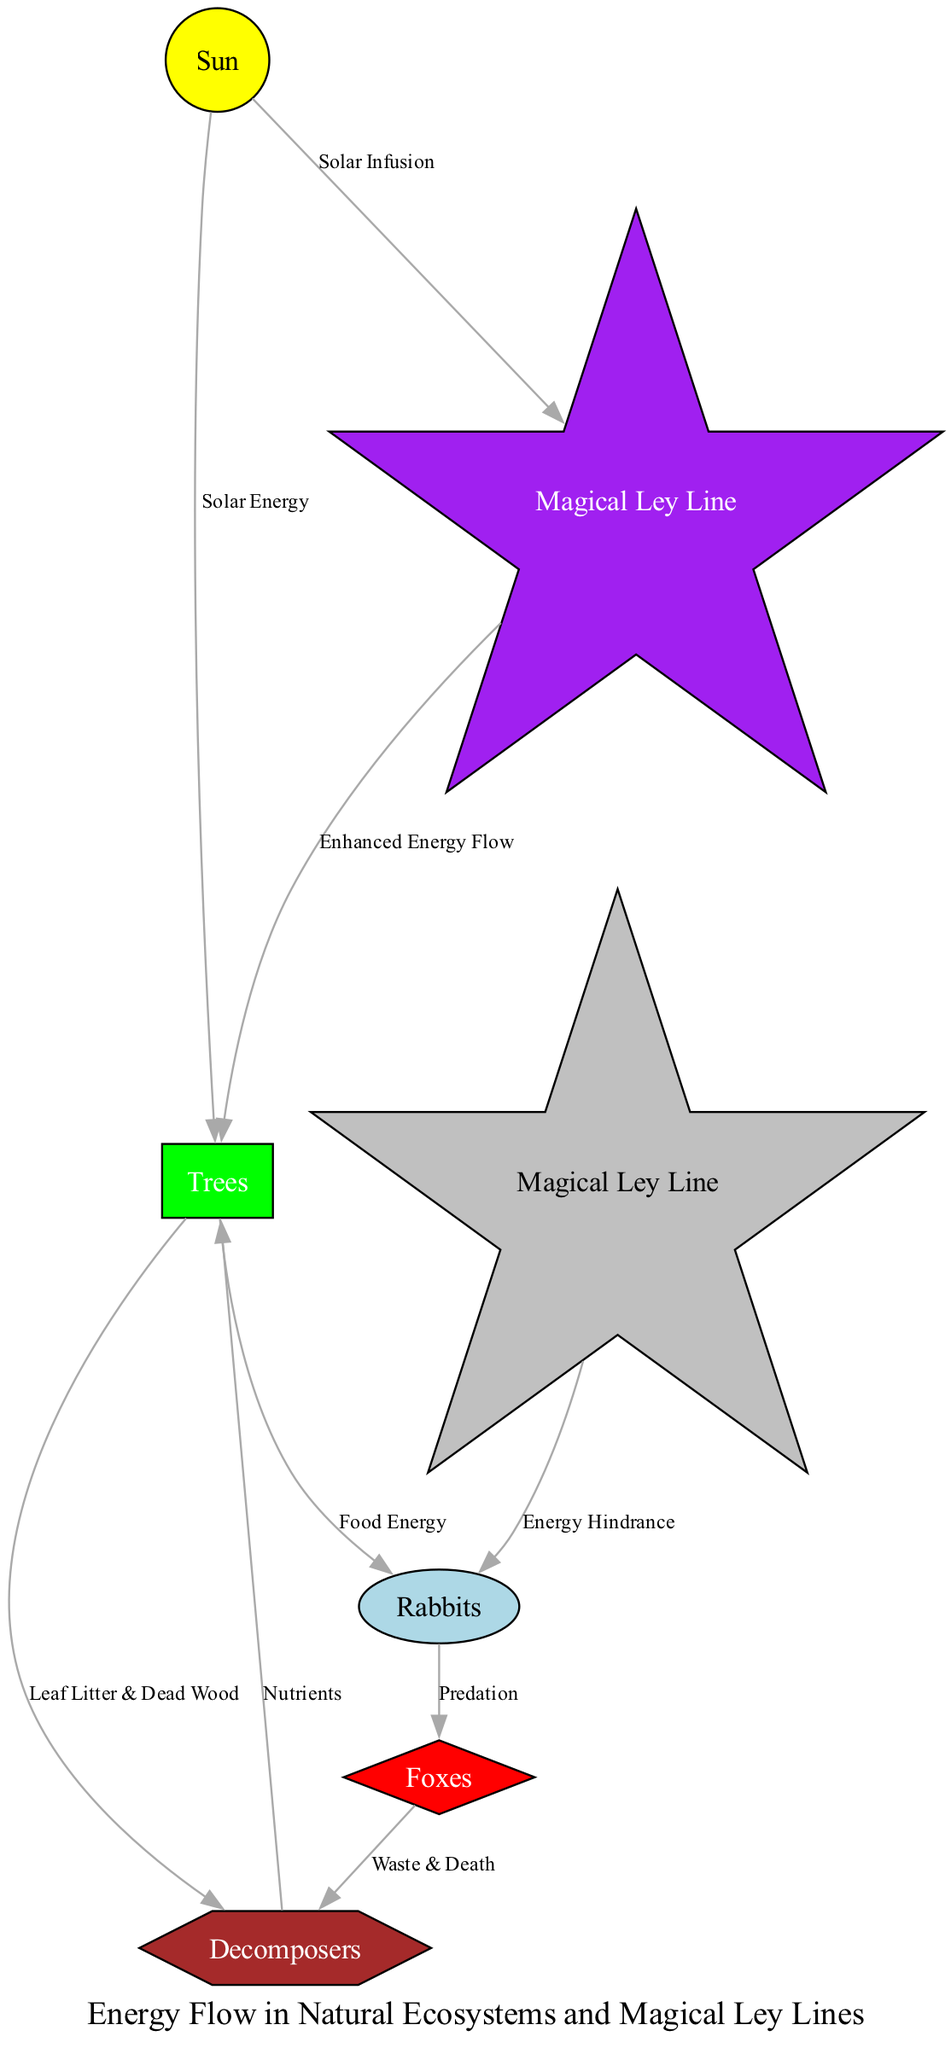What is the primary energy source in this ecosystem? The primary energy source is the Sun, as indicated by the node labeled 'Sun' and its connection to the trees, showing the energy transfer from the Sun to the primary producers.
Answer: Sun How many primary consumers are represented in the diagram? The diagram shows one primary consumer, which is the Rabbits node. There is only one connection from the trees (primary producers) to the rabbits, indicating there is only one type of primary consumer present.
Answer: 1 What type of energy transfer occurs between trees and rabbits? The energy transfer from trees to rabbits is labeled as "Food Energy," showing that the trees provide energy in the form of food to the rabbits.
Answer: Food Energy Which magical ley line enhances energy flow in the ecosystem? The magical ley line that enhances energy flow is labeled as "Magical Ley Line". It directly connects with both the sun and trees, supporting the idea of enhanced energy.
Answer: Magical Ley Line What is the impact of the magical ley line that hinders energy flow? The magical ley line that hinders energy flow negatively impacts the rabbits, as indicated by the edge labeled "Energy Hindrance". This shows that it reduces the energy available to the rabbits.
Answer: Energy Hindrance How many pathways connect decomposers to other nodes? There are three pathways connecting decomposers to other nodes: from foxes to decomposers, from trees to decomposers, and from decomposers back to trees, indicating interactions in nutrient cycling.
Answer: 3 Which node does not have any incoming edges? The Sun does not have any incoming edges; it is the initial energy source in the diagram, providing energy to other organisms without receiving energy from any other node.
Answer: Sun What type of relationship exists between foxes and decomposers? The relationship is labeled as "Waste & Death," indicating that the foxes contribute organic material (waste and dead bodies) that provides energy to the decomposers.
Answer: Waste & Death What is the nutrient relationship between decomposers and trees? The relationship is labeled "Nutrients," showing that decomposers return essential nutrients back to the trees, aiding in their growth and energy production.
Answer: Nutrients 